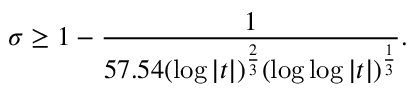<formula> <loc_0><loc_0><loc_500><loc_500>\sigma \geq 1 - { \frac { 1 } { 5 7 . 5 4 ( \log { | t | } ) ^ { \frac { 2 } { 3 } } ( \log { \log { | t | } } ) ^ { \frac { 1 } { 3 } } } } .</formula> 